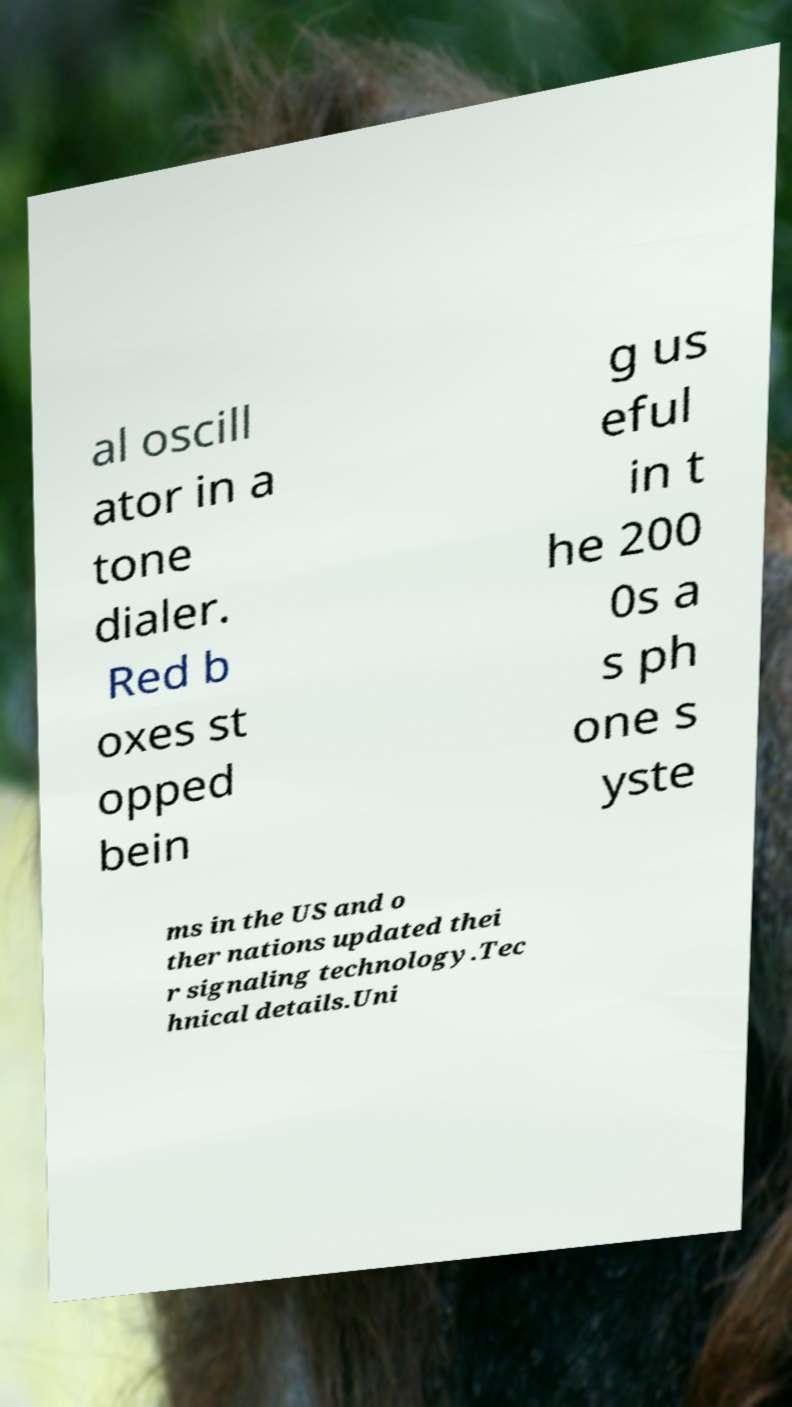Can you accurately transcribe the text from the provided image for me? al oscill ator in a tone dialer. Red b oxes st opped bein g us eful in t he 200 0s a s ph one s yste ms in the US and o ther nations updated thei r signaling technology.Tec hnical details.Uni 